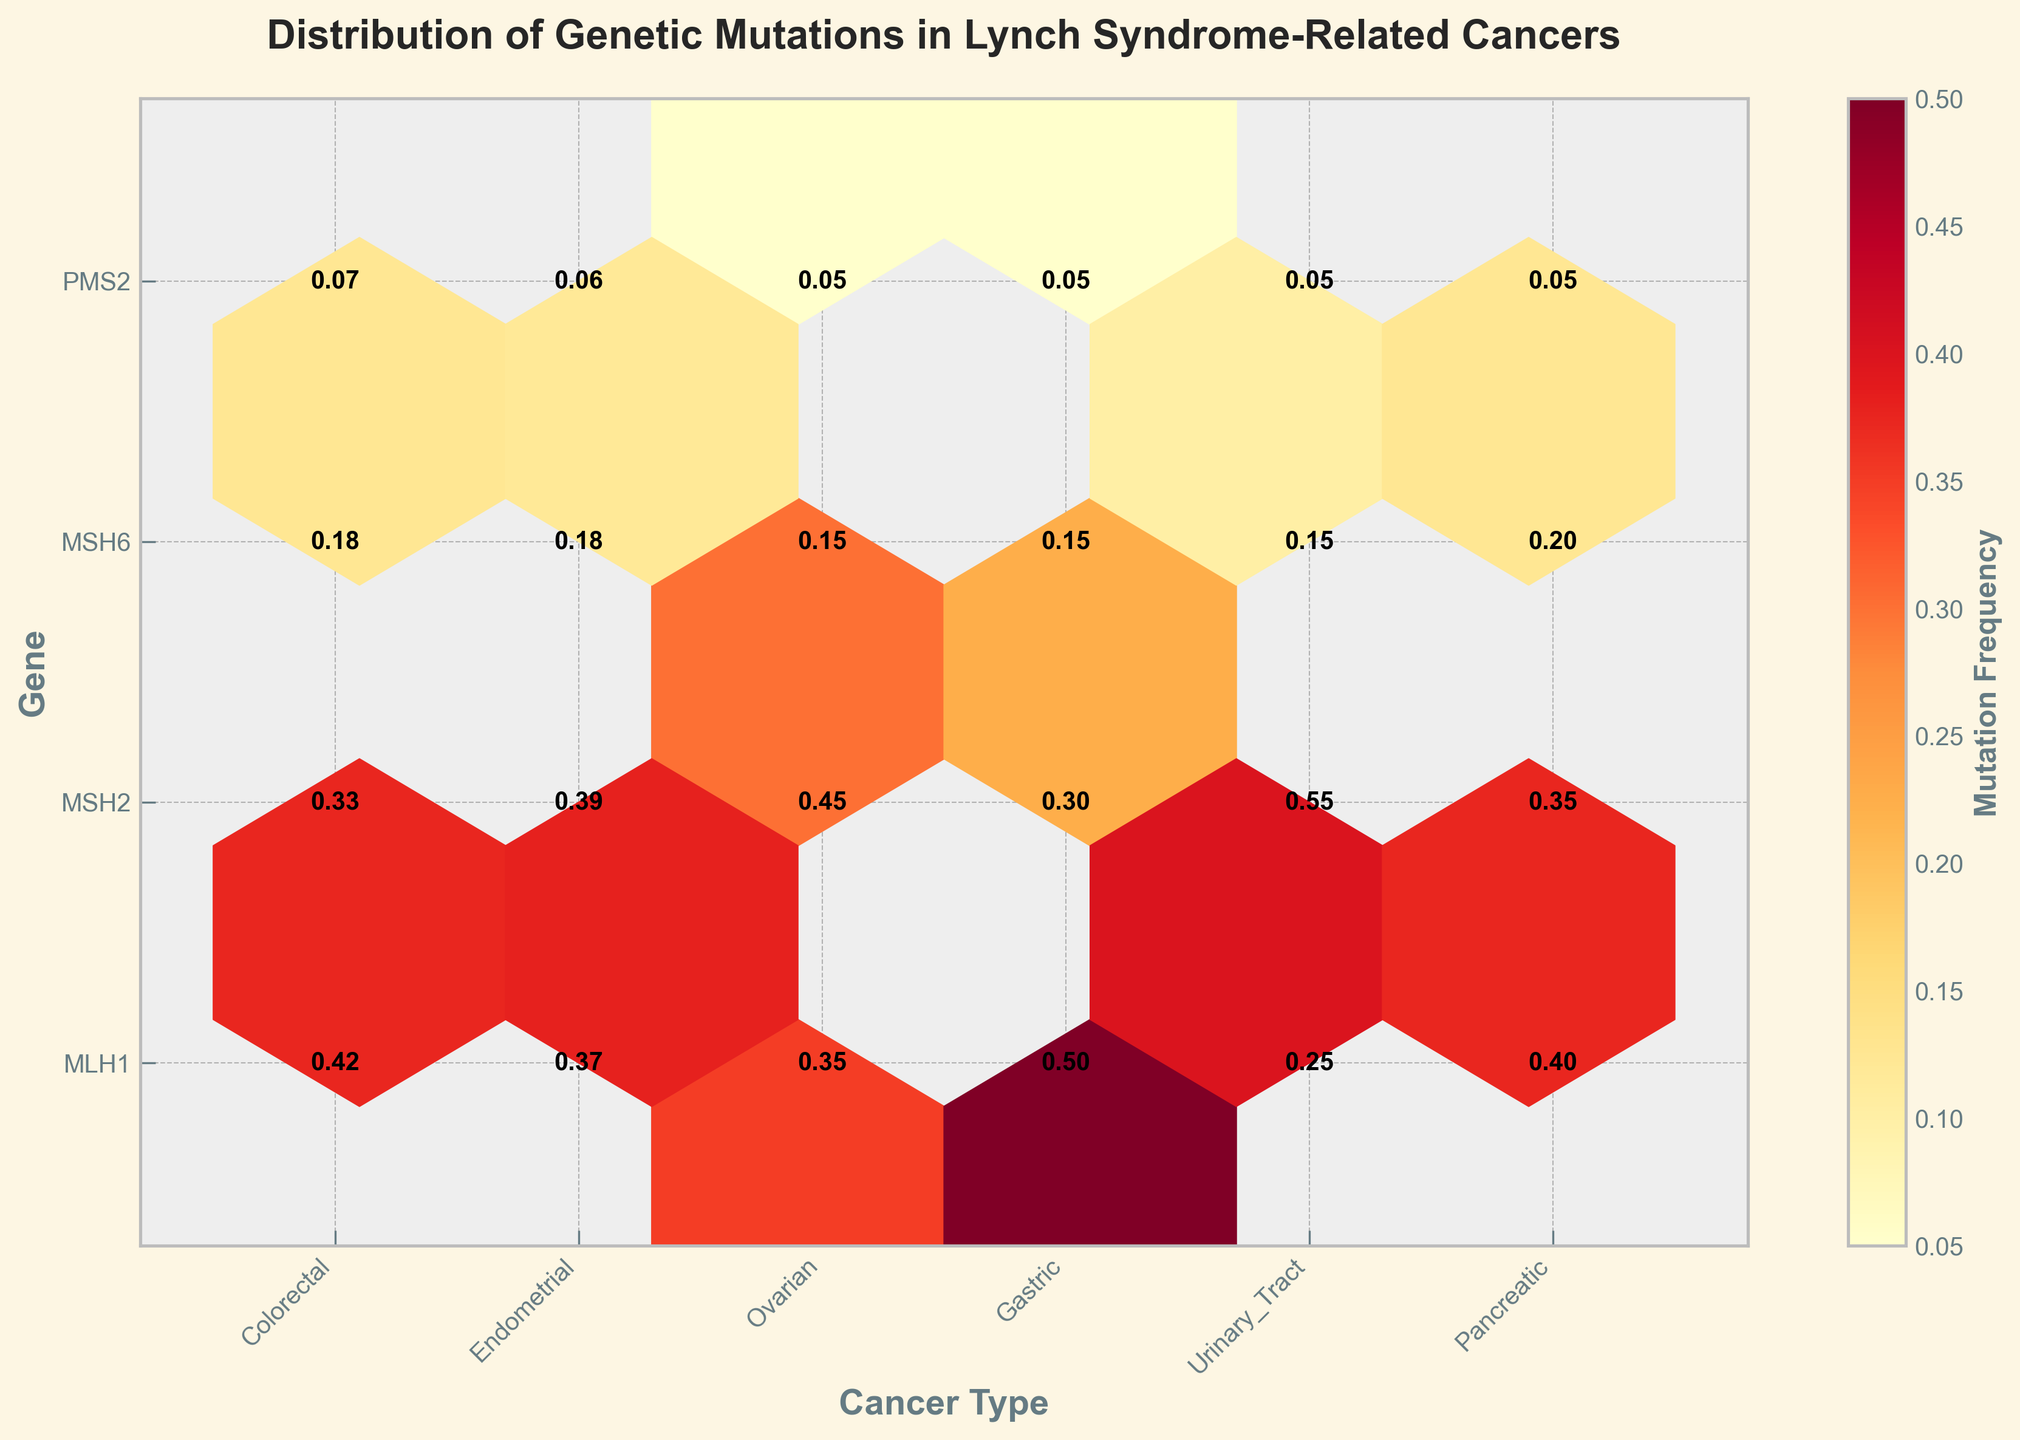What's the title of the plot? The title of the plot is a distinct element located at the top center of the figure. By quickly scanning the top area of the plot, the title text is displayed prominently.
Answer: Distribution of Genetic Mutations in Lynch Syndrome-Related Cancers What does the color intensity indicate in the hexbin plot? In a hexbin plot, the color intensity represents a certain variable. By observing the color bar legend usually found next to the plot, it's clear that the intensity correlates with mutation frequency.
Answer: Mutation Frequency Which cancer type has the highest mutation frequency for the MLH1 gene? To determine the highest mutation frequency for MLH1, locate the row labeled MLH1 on the y-axis and scan for the darkest hexbin, which corresponds to a high mutation value. According to the plot, Gastric cancer has the darkest hexbin in the MLH1 row.
Answer: Gastric What's the median mutation frequency for the genes in Colorectal cancer? To find the median mutation frequency for Colorectal cancer genes, list the mutation frequencies from the figure: 0.42, 0.33, 0.18, 0.07. Then arrange these in ascending order: 0.07, 0.18, 0.33, 0.42. The median is the average of the two middle numbers (0.18 and 0.33).
Answer: 0.255 Which gene demonstrates the most consistent mutation frequency across all cancer types? Consistency can be judged by looking for the gene where the color intensity (mutation frequency) values have the least variation across all cancer types. MSH6 has similar values (lighter shades consistently) across cancer types, indicating consistency.
Answer: MSH6 How do the mutation frequencies for MSH2 differ between Urinary Tract and Pancreatic cancer? Compare the hexbin color intensities for MSH2 rows for Urinary Tract and Pancreatic columns. Urinary Tract is darker at 0.55, while Pancreatic is lighter at 0.35. Subtract Pancreatic from Urinary Tract.
Answer: 0.20 higher in Urinary Tract Which cancer type shows the lowest mutation frequency for PMS2 and what is it? Identify the PMS2 row and look for the lightest hexbin color among the cancer types. Corresponding frequency and the labels should show this value. The lightest hexbin is for Endometrial cancer at 0.06.
Answer: Endometrial What is the average mutation frequency for MLH1 across all cancer types? List the frequencies for MLH1 obtained from the hexbin plot: 0.42 (Colorectal), 0.37 (Endometrial), 0.35 (Ovarian), 0.50 (Gastric), 0.25 (Urinary_Tract), 0.40 (Pancreatic). Sum these and divide by 6. (0.42 + 0.37 + 0.35 + 0.50 + 0.25 + 0.40) / 6
Answer: 0.38 Which cancer type has the greatest variation in mutation frequencies across all genes? To determine the variation, observe the difference in color intensities (mutation frequencies) within each cancer type column. Pancreatic cancer shows noticeable differences from 0.40 to 0.05 (the largest range).
Answer: Pancreatic 